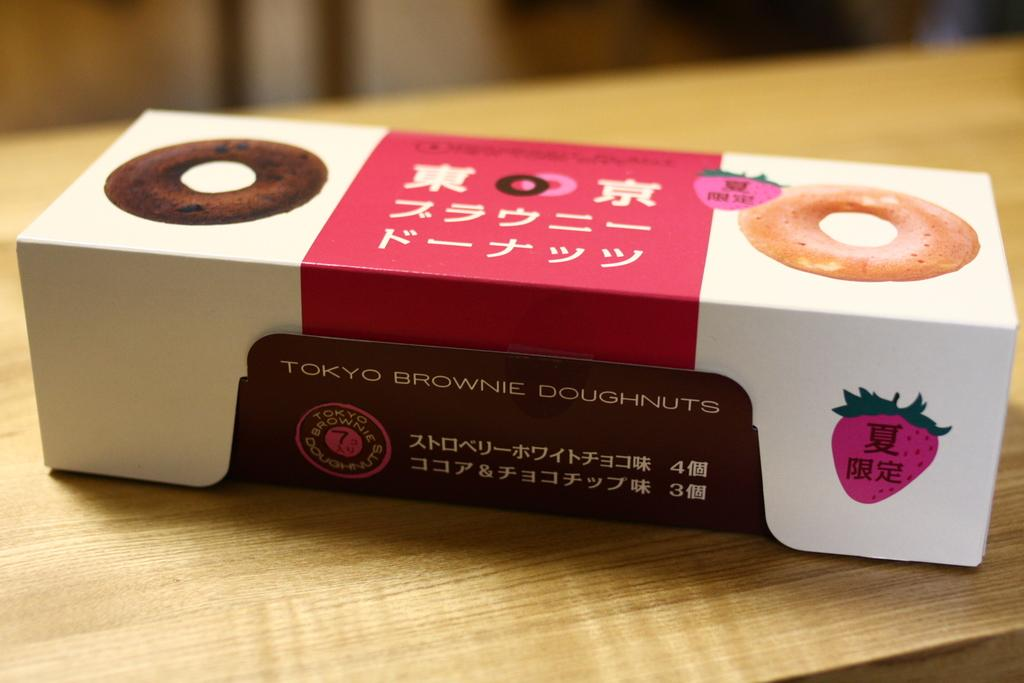What is the main object in the image? There is a doughnuts box in the image. Where is the doughnuts box located? The doughnuts box is placed on a table. What type of grip can be seen on the notebook in the image? There is no notebook present in the image, so there is no grip to observe. 